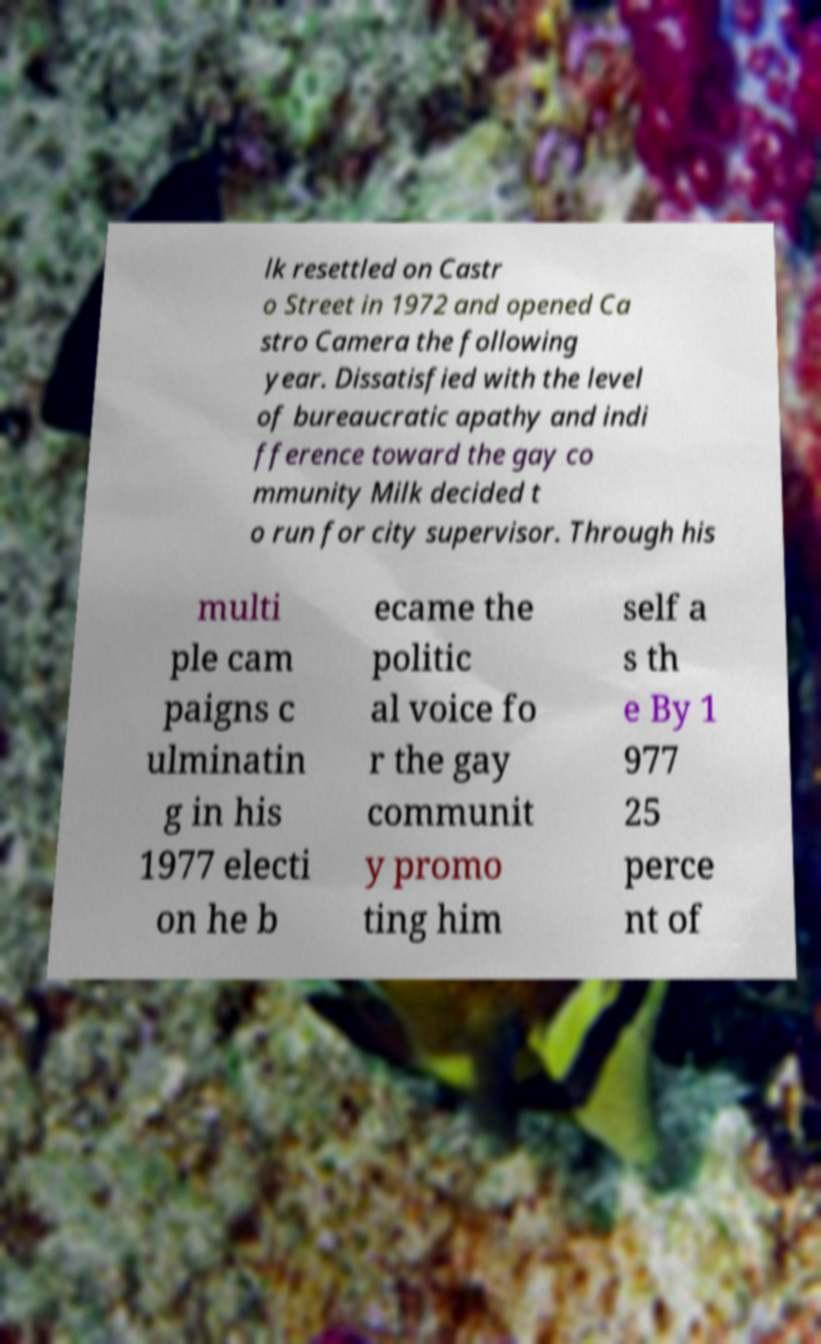Could you extract and type out the text from this image? lk resettled on Castr o Street in 1972 and opened Ca stro Camera the following year. Dissatisfied with the level of bureaucratic apathy and indi fference toward the gay co mmunity Milk decided t o run for city supervisor. Through his multi ple cam paigns c ulminatin g in his 1977 electi on he b ecame the politic al voice fo r the gay communit y promo ting him self a s th e By 1 977 25 perce nt of 